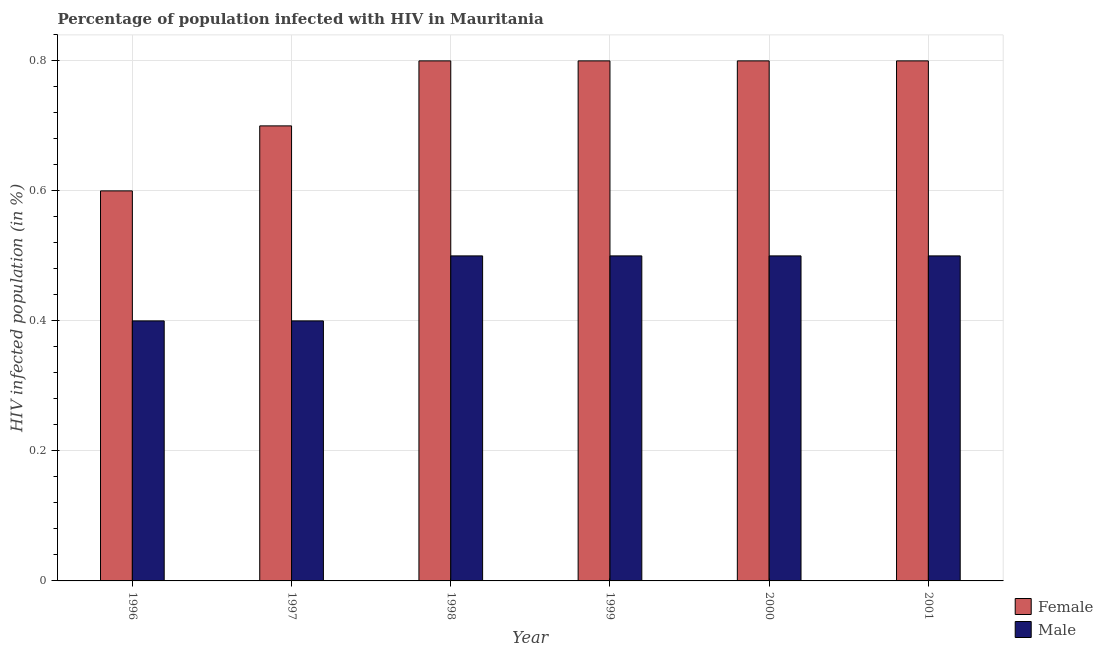How many different coloured bars are there?
Make the answer very short. 2. How many groups of bars are there?
Ensure brevity in your answer.  6. Are the number of bars per tick equal to the number of legend labels?
Give a very brief answer. Yes. How many bars are there on the 1st tick from the left?
Keep it short and to the point. 2. What is the label of the 1st group of bars from the left?
Keep it short and to the point. 1996. What is the percentage of males who are infected with hiv in 2001?
Provide a succinct answer. 0.5. Across all years, what is the minimum percentage of females who are infected with hiv?
Your response must be concise. 0.6. In which year was the percentage of females who are infected with hiv minimum?
Give a very brief answer. 1996. What is the difference between the percentage of males who are infected with hiv in 1999 and that in 2000?
Give a very brief answer. 0. What is the difference between the percentage of females who are infected with hiv in 1996 and the percentage of males who are infected with hiv in 1997?
Keep it short and to the point. -0.1. What is the average percentage of males who are infected with hiv per year?
Your response must be concise. 0.47. In the year 2000, what is the difference between the percentage of males who are infected with hiv and percentage of females who are infected with hiv?
Ensure brevity in your answer.  0. What is the ratio of the percentage of females who are infected with hiv in 1996 to that in 1998?
Keep it short and to the point. 0.75. What is the difference between the highest and the lowest percentage of males who are infected with hiv?
Offer a terse response. 0.1. In how many years, is the percentage of males who are infected with hiv greater than the average percentage of males who are infected with hiv taken over all years?
Give a very brief answer. 4. How many bars are there?
Provide a short and direct response. 12. Are all the bars in the graph horizontal?
Give a very brief answer. No. What is the difference between two consecutive major ticks on the Y-axis?
Give a very brief answer. 0.2. Are the values on the major ticks of Y-axis written in scientific E-notation?
Your response must be concise. No. Where does the legend appear in the graph?
Ensure brevity in your answer.  Bottom right. What is the title of the graph?
Provide a short and direct response. Percentage of population infected with HIV in Mauritania. Does "Time to import" appear as one of the legend labels in the graph?
Your answer should be very brief. No. What is the label or title of the Y-axis?
Provide a short and direct response. HIV infected population (in %). What is the HIV infected population (in %) of Female in 1996?
Offer a terse response. 0.6. What is the HIV infected population (in %) of Male in 1997?
Your response must be concise. 0.4. What is the HIV infected population (in %) in Male in 1998?
Ensure brevity in your answer.  0.5. What is the HIV infected population (in %) of Female in 2000?
Offer a very short reply. 0.8. What is the HIV infected population (in %) of Female in 2001?
Keep it short and to the point. 0.8. What is the HIV infected population (in %) in Male in 2001?
Offer a terse response. 0.5. Across all years, what is the maximum HIV infected population (in %) in Female?
Your answer should be very brief. 0.8. Across all years, what is the minimum HIV infected population (in %) in Male?
Provide a short and direct response. 0.4. What is the total HIV infected population (in %) in Female in the graph?
Your answer should be very brief. 4.5. What is the difference between the HIV infected population (in %) of Male in 1996 and that in 1998?
Ensure brevity in your answer.  -0.1. What is the difference between the HIV infected population (in %) in Female in 1997 and that in 1998?
Offer a terse response. -0.1. What is the difference between the HIV infected population (in %) in Female in 1997 and that in 1999?
Provide a succinct answer. -0.1. What is the difference between the HIV infected population (in %) of Male in 1997 and that in 1999?
Offer a very short reply. -0.1. What is the difference between the HIV infected population (in %) in Female in 1997 and that in 2000?
Make the answer very short. -0.1. What is the difference between the HIV infected population (in %) of Male in 1997 and that in 2000?
Your answer should be compact. -0.1. What is the difference between the HIV infected population (in %) of Female in 1997 and that in 2001?
Keep it short and to the point. -0.1. What is the difference between the HIV infected population (in %) of Female in 1998 and that in 1999?
Provide a short and direct response. 0. What is the difference between the HIV infected population (in %) of Male in 1998 and that in 1999?
Your answer should be very brief. 0. What is the difference between the HIV infected population (in %) in Male in 1998 and that in 2000?
Your answer should be compact. 0. What is the difference between the HIV infected population (in %) in Female in 1998 and that in 2001?
Offer a terse response. 0. What is the difference between the HIV infected population (in %) of Female in 1999 and that in 2000?
Give a very brief answer. 0. What is the difference between the HIV infected population (in %) of Female in 1999 and that in 2001?
Your answer should be very brief. 0. What is the difference between the HIV infected population (in %) of Female in 1996 and the HIV infected population (in %) of Male in 1998?
Provide a short and direct response. 0.1. What is the difference between the HIV infected population (in %) in Female in 1996 and the HIV infected population (in %) in Male in 2000?
Offer a very short reply. 0.1. What is the difference between the HIV infected population (in %) in Female in 1997 and the HIV infected population (in %) in Male in 2000?
Your response must be concise. 0.2. What is the difference between the HIV infected population (in %) in Female in 1998 and the HIV infected population (in %) in Male in 2001?
Give a very brief answer. 0.3. What is the difference between the HIV infected population (in %) in Female in 1999 and the HIV infected population (in %) in Male in 2000?
Offer a terse response. 0.3. What is the difference between the HIV infected population (in %) in Female in 1999 and the HIV infected population (in %) in Male in 2001?
Give a very brief answer. 0.3. What is the average HIV infected population (in %) in Male per year?
Provide a short and direct response. 0.47. In the year 1999, what is the difference between the HIV infected population (in %) in Female and HIV infected population (in %) in Male?
Offer a very short reply. 0.3. In the year 2001, what is the difference between the HIV infected population (in %) of Female and HIV infected population (in %) of Male?
Provide a succinct answer. 0.3. What is the ratio of the HIV infected population (in %) of Male in 1996 to that in 1997?
Offer a very short reply. 1. What is the ratio of the HIV infected population (in %) of Male in 1996 to that in 1998?
Ensure brevity in your answer.  0.8. What is the ratio of the HIV infected population (in %) in Female in 1996 to that in 1999?
Keep it short and to the point. 0.75. What is the ratio of the HIV infected population (in %) in Female in 1996 to that in 2000?
Provide a succinct answer. 0.75. What is the ratio of the HIV infected population (in %) in Female in 1996 to that in 2001?
Ensure brevity in your answer.  0.75. What is the ratio of the HIV infected population (in %) in Male in 1996 to that in 2001?
Offer a terse response. 0.8. What is the ratio of the HIV infected population (in %) of Male in 1997 to that in 2000?
Ensure brevity in your answer.  0.8. What is the ratio of the HIV infected population (in %) of Female in 1997 to that in 2001?
Ensure brevity in your answer.  0.88. What is the ratio of the HIV infected population (in %) of Male in 1997 to that in 2001?
Your answer should be compact. 0.8. What is the ratio of the HIV infected population (in %) in Female in 1998 to that in 2000?
Your answer should be compact. 1. What is the ratio of the HIV infected population (in %) of Male in 1998 to that in 2000?
Provide a succinct answer. 1. What is the ratio of the HIV infected population (in %) in Male in 1998 to that in 2001?
Offer a very short reply. 1. What is the ratio of the HIV infected population (in %) of Female in 1999 to that in 2000?
Offer a very short reply. 1. What is the ratio of the HIV infected population (in %) of Male in 1999 to that in 2001?
Provide a short and direct response. 1. What is the ratio of the HIV infected population (in %) of Male in 2000 to that in 2001?
Offer a terse response. 1. What is the difference between the highest and the second highest HIV infected population (in %) of Male?
Offer a terse response. 0. What is the difference between the highest and the lowest HIV infected population (in %) in Female?
Offer a very short reply. 0.2. What is the difference between the highest and the lowest HIV infected population (in %) in Male?
Your response must be concise. 0.1. 